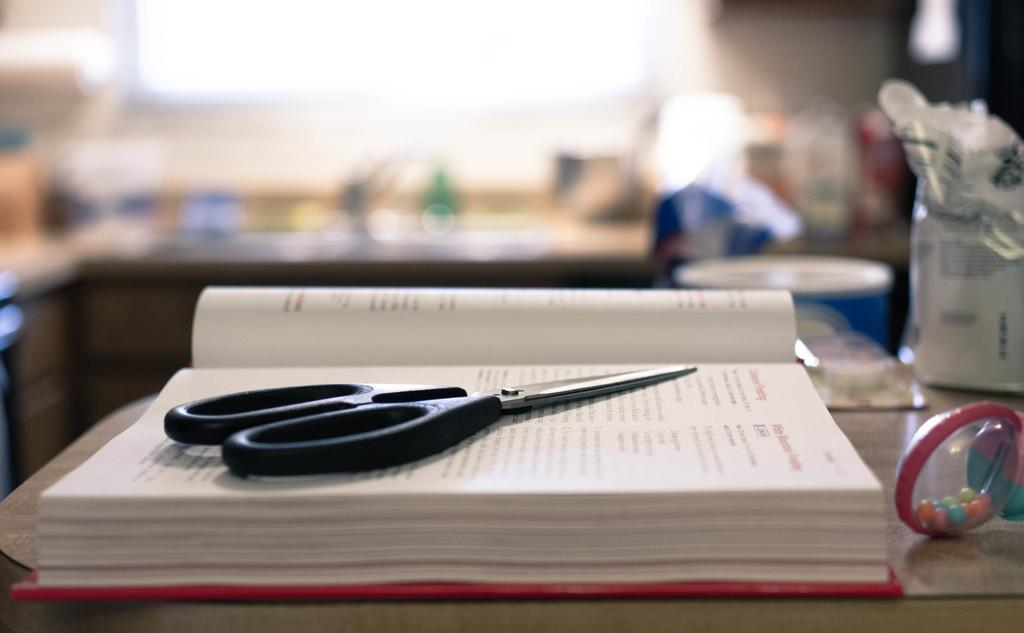What object can be seen on top of the book in the image? A scissor is placed on the book. Where are the book and scissor located? The book and scissor are on a table. What other item is present on the table in the image? There is a toy beside the book. What might be used to cut paper or fabric in the image? The scissor on the book could be used for cutting paper or fabric. What type of print can be seen on the toy in the image? There is no print visible on the toy in the image. How does the toy expand in the image? The toy does not expand in the image; it is a stationary object beside the book. 